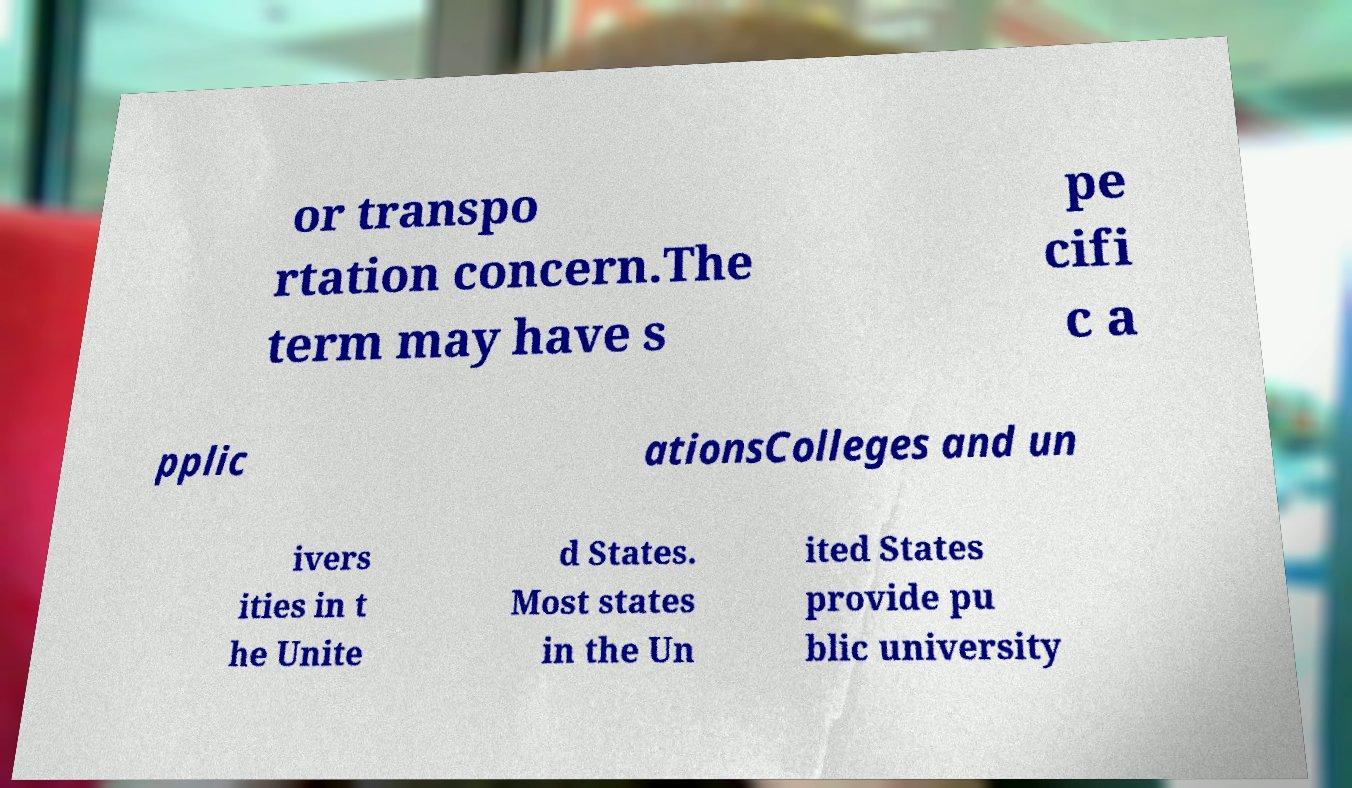Can you accurately transcribe the text from the provided image for me? or transpo rtation concern.The term may have s pe cifi c a pplic ationsColleges and un ivers ities in t he Unite d States. Most states in the Un ited States provide pu blic university 